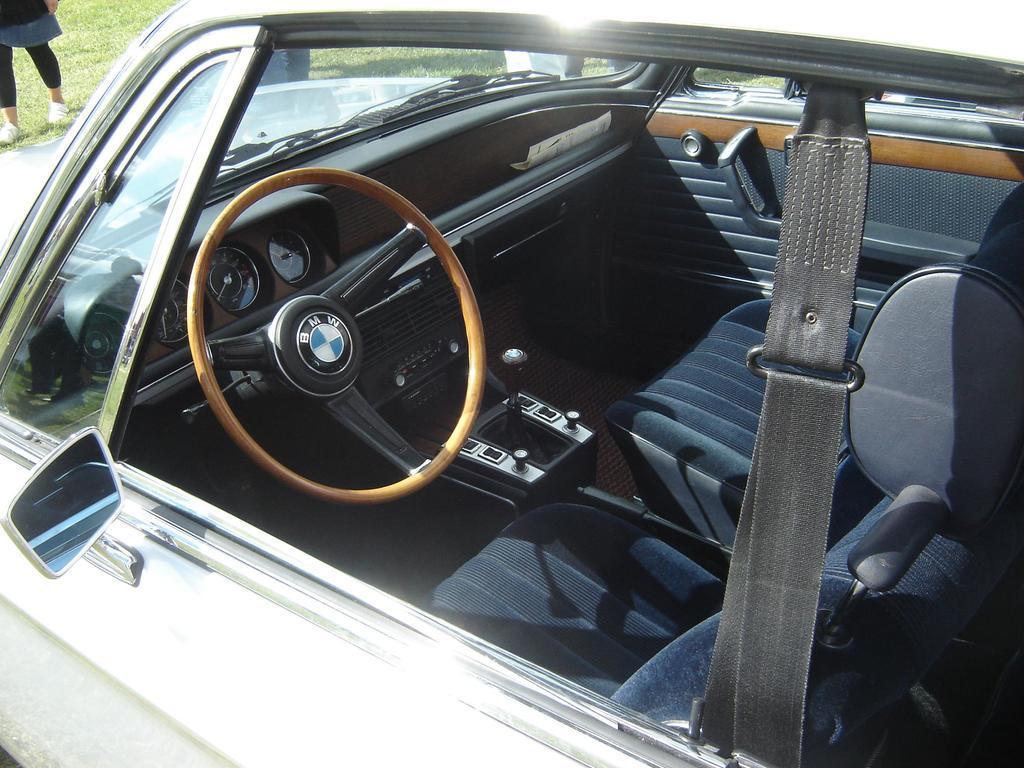Please provide a concise description of this image. In this image there is a car and a person standing on the grass. 